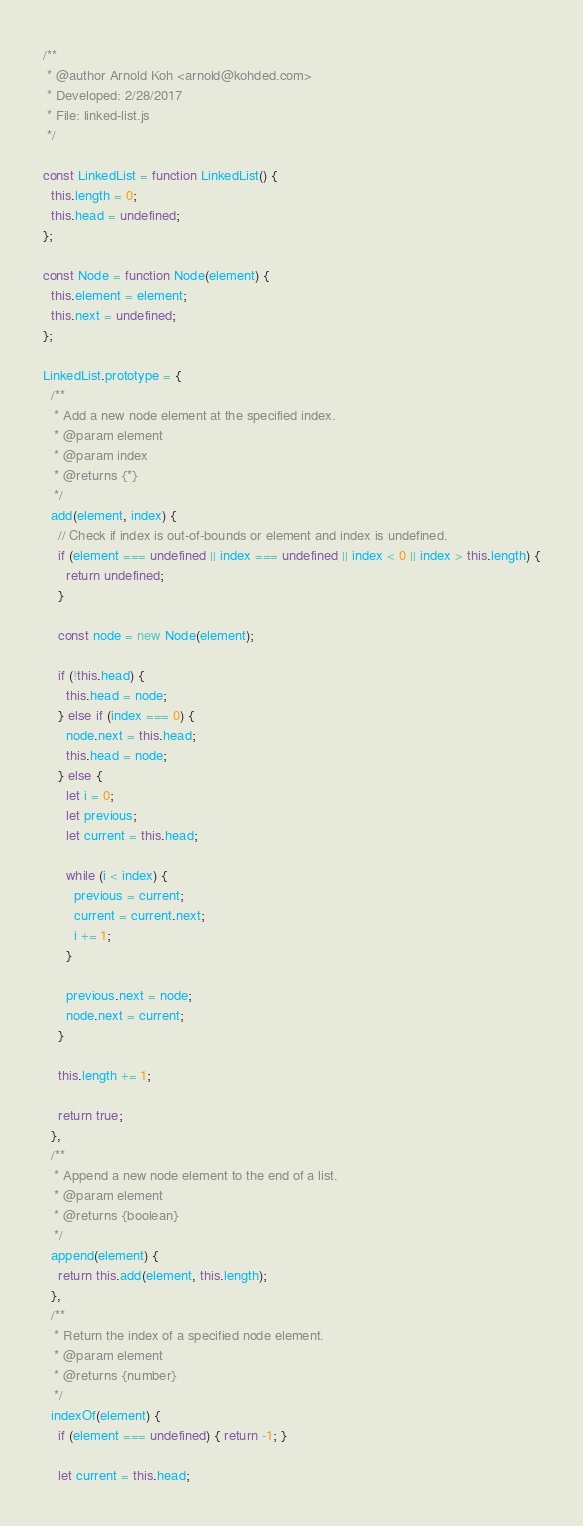<code> <loc_0><loc_0><loc_500><loc_500><_JavaScript_>/**
 * @author Arnold Koh <arnold@kohded.com>
 * Developed: 2/28/2017
 * File: linked-list.js
 */

const LinkedList = function LinkedList() {
  this.length = 0;
  this.head = undefined;
};

const Node = function Node(element) {
  this.element = element;
  this.next = undefined;
};

LinkedList.prototype = {
  /**
   * Add a new node element at the specified index.
   * @param element
   * @param index
   * @returns {*}
   */
  add(element, index) {
    // Check if index is out-of-bounds or element and index is undefined.
    if (element === undefined || index === undefined || index < 0 || index > this.length) {
      return undefined;
    }

    const node = new Node(element);

    if (!this.head) {
      this.head = node;
    } else if (index === 0) {
      node.next = this.head;
      this.head = node;
    } else {
      let i = 0;
      let previous;
      let current = this.head;

      while (i < index) {
        previous = current;
        current = current.next;
        i += 1;
      }

      previous.next = node;
      node.next = current;
    }

    this.length += 1;

    return true;
  },
  /**
   * Append a new node element to the end of a list.
   * @param element
   * @returns {boolean}
   */
  append(element) {
    return this.add(element, this.length);
  },
  /**
   * Return the index of a specified node element.
   * @param element
   * @returns {number}
   */
  indexOf(element) {
    if (element === undefined) { return -1; }

    let current = this.head;</code> 